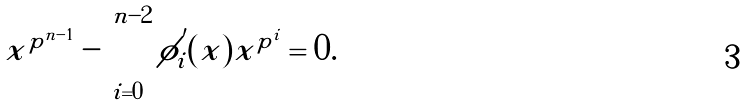<formula> <loc_0><loc_0><loc_500><loc_500>x ^ { p ^ { n - 1 } } - \sum _ { i = 0 } ^ { n - 2 } \phi ^ { ^ { \prime } } _ { i } ( x ) x ^ { p ^ { i } } = 0 .</formula> 